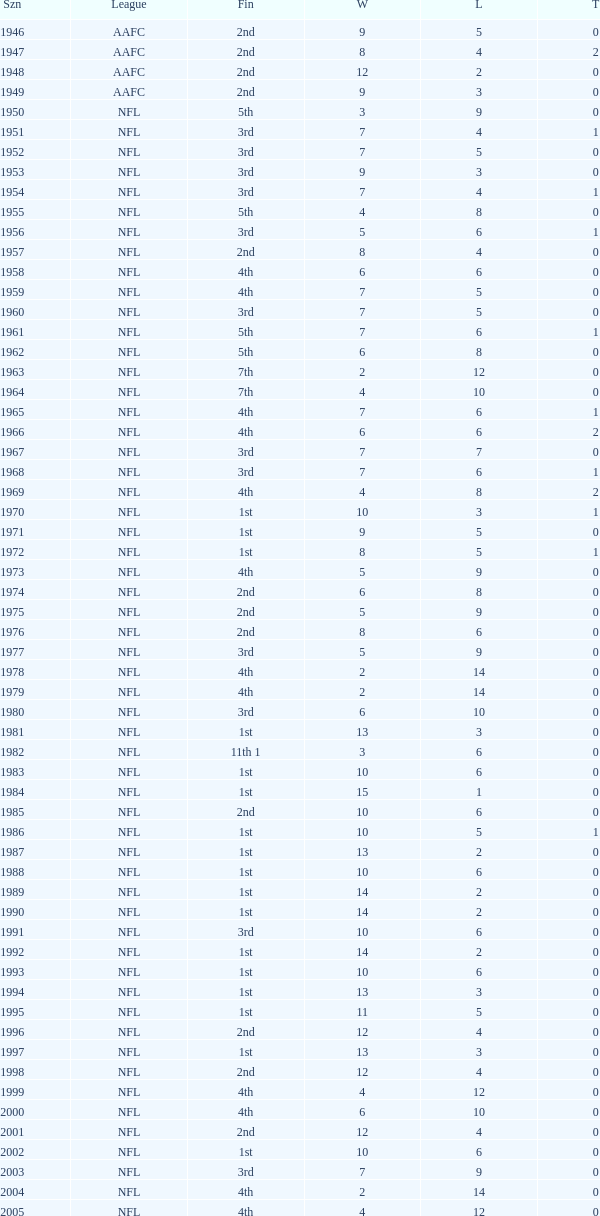What league had a finish of 2nd and 3 losses? AAFC. 